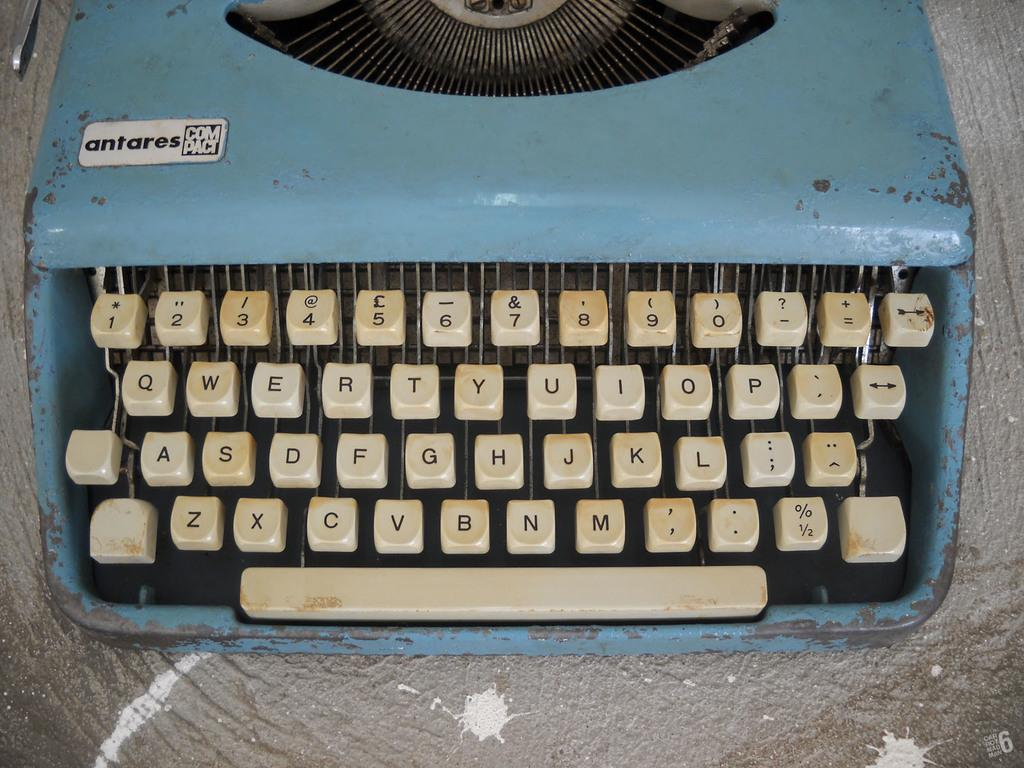<image>
Describe the image concisely. An old blue Antares compact typewriter looks like it needs to be cleaned. 